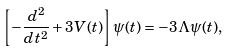<formula> <loc_0><loc_0><loc_500><loc_500>\left [ - \frac { d ^ { 2 } } { d t ^ { 2 } } + 3 V ( t ) \right ] \psi ( t ) = - 3 \Lambda \psi ( t ) ,</formula> 